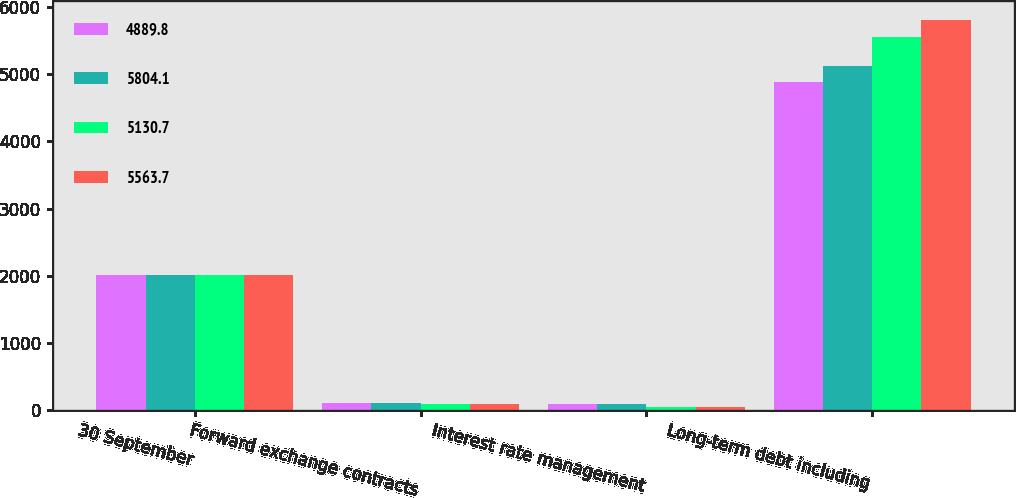Convert chart to OTSL. <chart><loc_0><loc_0><loc_500><loc_500><stacked_bar_chart><ecel><fcel>30 September<fcel>Forward exchange contracts<fcel>Interest rate management<fcel>Long-term debt including<nl><fcel>4889.8<fcel>2014<fcel>93.4<fcel>78.3<fcel>4889.8<nl><fcel>5804.1<fcel>2014<fcel>93.4<fcel>78.3<fcel>5130.7<nl><fcel>5130.7<fcel>2013<fcel>90.5<fcel>35.4<fcel>5563.7<nl><fcel>5563.7<fcel>2013<fcel>90.5<fcel>35.4<fcel>5804.1<nl></chart> 